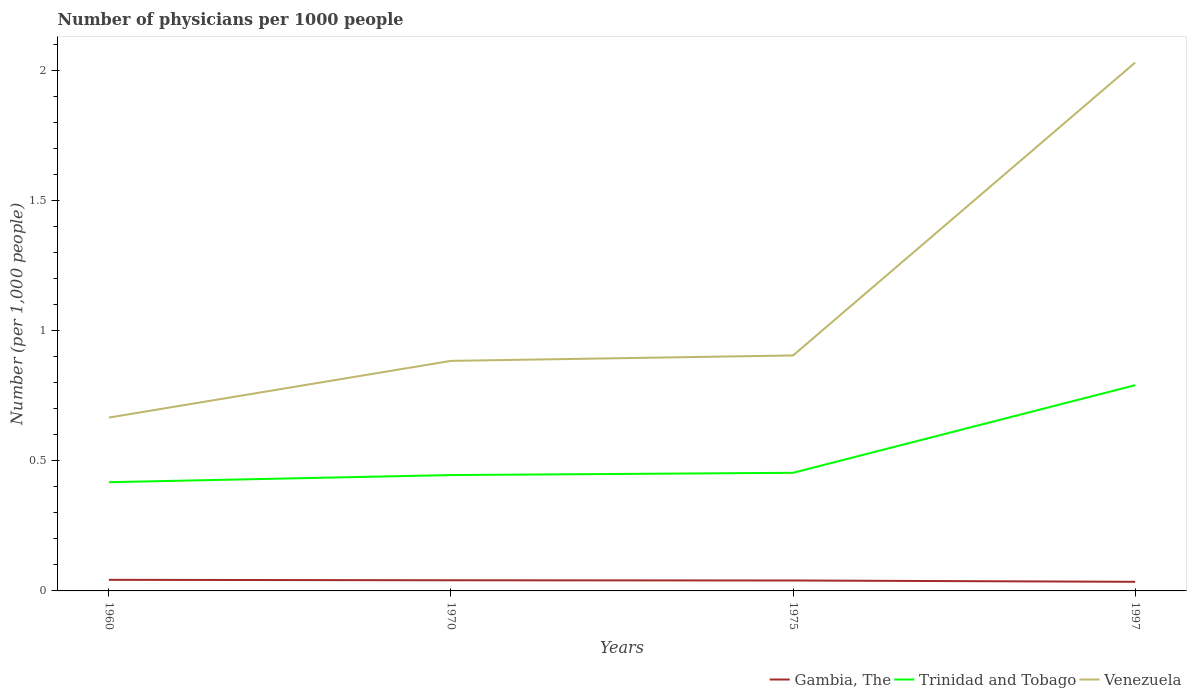How many different coloured lines are there?
Provide a short and direct response. 3. Is the number of lines equal to the number of legend labels?
Your answer should be compact. Yes. Across all years, what is the maximum number of physicians in Trinidad and Tobago?
Give a very brief answer. 0.42. What is the total number of physicians in Gambia, The in the graph?
Ensure brevity in your answer.  0.01. What is the difference between the highest and the second highest number of physicians in Venezuela?
Offer a very short reply. 1.36. How many lines are there?
Offer a very short reply. 3. How many years are there in the graph?
Give a very brief answer. 4. What is the difference between two consecutive major ticks on the Y-axis?
Make the answer very short. 0.5. Are the values on the major ticks of Y-axis written in scientific E-notation?
Your answer should be very brief. No. Does the graph contain any zero values?
Give a very brief answer. No. How are the legend labels stacked?
Ensure brevity in your answer.  Horizontal. What is the title of the graph?
Your answer should be very brief. Number of physicians per 1000 people. What is the label or title of the X-axis?
Keep it short and to the point. Years. What is the label or title of the Y-axis?
Keep it short and to the point. Number (per 1,0 people). What is the Number (per 1,000 people) of Gambia, The in 1960?
Give a very brief answer. 0.04. What is the Number (per 1,000 people) in Trinidad and Tobago in 1960?
Offer a very short reply. 0.42. What is the Number (per 1,000 people) in Venezuela in 1960?
Provide a succinct answer. 0.67. What is the Number (per 1,000 people) of Gambia, The in 1970?
Provide a short and direct response. 0.04. What is the Number (per 1,000 people) of Trinidad and Tobago in 1970?
Keep it short and to the point. 0.44. What is the Number (per 1,000 people) of Venezuela in 1970?
Your answer should be very brief. 0.88. What is the Number (per 1,000 people) in Gambia, The in 1975?
Offer a very short reply. 0.04. What is the Number (per 1,000 people) in Trinidad and Tobago in 1975?
Make the answer very short. 0.45. What is the Number (per 1,000 people) in Venezuela in 1975?
Offer a terse response. 0.9. What is the Number (per 1,000 people) of Gambia, The in 1997?
Give a very brief answer. 0.04. What is the Number (per 1,000 people) of Trinidad and Tobago in 1997?
Give a very brief answer. 0.79. What is the Number (per 1,000 people) in Venezuela in 1997?
Offer a terse response. 2.03. Across all years, what is the maximum Number (per 1,000 people) in Gambia, The?
Give a very brief answer. 0.04. Across all years, what is the maximum Number (per 1,000 people) of Trinidad and Tobago?
Ensure brevity in your answer.  0.79. Across all years, what is the maximum Number (per 1,000 people) of Venezuela?
Offer a very short reply. 2.03. Across all years, what is the minimum Number (per 1,000 people) in Gambia, The?
Keep it short and to the point. 0.04. Across all years, what is the minimum Number (per 1,000 people) of Trinidad and Tobago?
Provide a short and direct response. 0.42. Across all years, what is the minimum Number (per 1,000 people) in Venezuela?
Make the answer very short. 0.67. What is the total Number (per 1,000 people) in Gambia, The in the graph?
Offer a terse response. 0.16. What is the total Number (per 1,000 people) in Trinidad and Tobago in the graph?
Provide a short and direct response. 2.11. What is the total Number (per 1,000 people) in Venezuela in the graph?
Offer a terse response. 4.48. What is the difference between the Number (per 1,000 people) in Gambia, The in 1960 and that in 1970?
Your answer should be very brief. 0. What is the difference between the Number (per 1,000 people) of Trinidad and Tobago in 1960 and that in 1970?
Offer a very short reply. -0.03. What is the difference between the Number (per 1,000 people) in Venezuela in 1960 and that in 1970?
Provide a short and direct response. -0.22. What is the difference between the Number (per 1,000 people) in Gambia, The in 1960 and that in 1975?
Your response must be concise. 0. What is the difference between the Number (per 1,000 people) of Trinidad and Tobago in 1960 and that in 1975?
Give a very brief answer. -0.04. What is the difference between the Number (per 1,000 people) in Venezuela in 1960 and that in 1975?
Your answer should be very brief. -0.24. What is the difference between the Number (per 1,000 people) in Gambia, The in 1960 and that in 1997?
Your response must be concise. 0.01. What is the difference between the Number (per 1,000 people) of Trinidad and Tobago in 1960 and that in 1997?
Provide a succinct answer. -0.37. What is the difference between the Number (per 1,000 people) in Venezuela in 1960 and that in 1997?
Your answer should be very brief. -1.36. What is the difference between the Number (per 1,000 people) in Gambia, The in 1970 and that in 1975?
Keep it short and to the point. 0. What is the difference between the Number (per 1,000 people) in Trinidad and Tobago in 1970 and that in 1975?
Ensure brevity in your answer.  -0.01. What is the difference between the Number (per 1,000 people) of Venezuela in 1970 and that in 1975?
Provide a succinct answer. -0.02. What is the difference between the Number (per 1,000 people) of Gambia, The in 1970 and that in 1997?
Ensure brevity in your answer.  0.01. What is the difference between the Number (per 1,000 people) of Trinidad and Tobago in 1970 and that in 1997?
Your response must be concise. -0.35. What is the difference between the Number (per 1,000 people) of Venezuela in 1970 and that in 1997?
Offer a terse response. -1.15. What is the difference between the Number (per 1,000 people) in Gambia, The in 1975 and that in 1997?
Provide a succinct answer. 0.01. What is the difference between the Number (per 1,000 people) in Trinidad and Tobago in 1975 and that in 1997?
Provide a short and direct response. -0.34. What is the difference between the Number (per 1,000 people) in Venezuela in 1975 and that in 1997?
Your answer should be compact. -1.12. What is the difference between the Number (per 1,000 people) in Gambia, The in 1960 and the Number (per 1,000 people) in Trinidad and Tobago in 1970?
Give a very brief answer. -0.4. What is the difference between the Number (per 1,000 people) in Gambia, The in 1960 and the Number (per 1,000 people) in Venezuela in 1970?
Provide a short and direct response. -0.84. What is the difference between the Number (per 1,000 people) of Trinidad and Tobago in 1960 and the Number (per 1,000 people) of Venezuela in 1970?
Your response must be concise. -0.47. What is the difference between the Number (per 1,000 people) of Gambia, The in 1960 and the Number (per 1,000 people) of Trinidad and Tobago in 1975?
Your answer should be very brief. -0.41. What is the difference between the Number (per 1,000 people) in Gambia, The in 1960 and the Number (per 1,000 people) in Venezuela in 1975?
Ensure brevity in your answer.  -0.86. What is the difference between the Number (per 1,000 people) of Trinidad and Tobago in 1960 and the Number (per 1,000 people) of Venezuela in 1975?
Keep it short and to the point. -0.49. What is the difference between the Number (per 1,000 people) of Gambia, The in 1960 and the Number (per 1,000 people) of Trinidad and Tobago in 1997?
Make the answer very short. -0.75. What is the difference between the Number (per 1,000 people) of Gambia, The in 1960 and the Number (per 1,000 people) of Venezuela in 1997?
Provide a succinct answer. -1.99. What is the difference between the Number (per 1,000 people) in Trinidad and Tobago in 1960 and the Number (per 1,000 people) in Venezuela in 1997?
Your response must be concise. -1.61. What is the difference between the Number (per 1,000 people) in Gambia, The in 1970 and the Number (per 1,000 people) in Trinidad and Tobago in 1975?
Keep it short and to the point. -0.41. What is the difference between the Number (per 1,000 people) of Gambia, The in 1970 and the Number (per 1,000 people) of Venezuela in 1975?
Offer a very short reply. -0.86. What is the difference between the Number (per 1,000 people) of Trinidad and Tobago in 1970 and the Number (per 1,000 people) of Venezuela in 1975?
Ensure brevity in your answer.  -0.46. What is the difference between the Number (per 1,000 people) in Gambia, The in 1970 and the Number (per 1,000 people) in Trinidad and Tobago in 1997?
Your answer should be compact. -0.75. What is the difference between the Number (per 1,000 people) in Gambia, The in 1970 and the Number (per 1,000 people) in Venezuela in 1997?
Your answer should be compact. -1.99. What is the difference between the Number (per 1,000 people) of Trinidad and Tobago in 1970 and the Number (per 1,000 people) of Venezuela in 1997?
Keep it short and to the point. -1.58. What is the difference between the Number (per 1,000 people) of Gambia, The in 1975 and the Number (per 1,000 people) of Trinidad and Tobago in 1997?
Ensure brevity in your answer.  -0.75. What is the difference between the Number (per 1,000 people) in Gambia, The in 1975 and the Number (per 1,000 people) in Venezuela in 1997?
Your answer should be very brief. -1.99. What is the difference between the Number (per 1,000 people) in Trinidad and Tobago in 1975 and the Number (per 1,000 people) in Venezuela in 1997?
Give a very brief answer. -1.58. What is the average Number (per 1,000 people) of Gambia, The per year?
Give a very brief answer. 0.04. What is the average Number (per 1,000 people) of Trinidad and Tobago per year?
Make the answer very short. 0.53. What is the average Number (per 1,000 people) of Venezuela per year?
Offer a very short reply. 1.12. In the year 1960, what is the difference between the Number (per 1,000 people) of Gambia, The and Number (per 1,000 people) of Trinidad and Tobago?
Offer a very short reply. -0.37. In the year 1960, what is the difference between the Number (per 1,000 people) in Gambia, The and Number (per 1,000 people) in Venezuela?
Your response must be concise. -0.62. In the year 1960, what is the difference between the Number (per 1,000 people) of Trinidad and Tobago and Number (per 1,000 people) of Venezuela?
Offer a terse response. -0.25. In the year 1970, what is the difference between the Number (per 1,000 people) in Gambia, The and Number (per 1,000 people) in Trinidad and Tobago?
Offer a very short reply. -0.4. In the year 1970, what is the difference between the Number (per 1,000 people) in Gambia, The and Number (per 1,000 people) in Venezuela?
Your response must be concise. -0.84. In the year 1970, what is the difference between the Number (per 1,000 people) of Trinidad and Tobago and Number (per 1,000 people) of Venezuela?
Give a very brief answer. -0.44. In the year 1975, what is the difference between the Number (per 1,000 people) in Gambia, The and Number (per 1,000 people) in Trinidad and Tobago?
Your answer should be compact. -0.41. In the year 1975, what is the difference between the Number (per 1,000 people) in Gambia, The and Number (per 1,000 people) in Venezuela?
Provide a succinct answer. -0.86. In the year 1975, what is the difference between the Number (per 1,000 people) of Trinidad and Tobago and Number (per 1,000 people) of Venezuela?
Ensure brevity in your answer.  -0.45. In the year 1997, what is the difference between the Number (per 1,000 people) in Gambia, The and Number (per 1,000 people) in Trinidad and Tobago?
Offer a terse response. -0.76. In the year 1997, what is the difference between the Number (per 1,000 people) of Gambia, The and Number (per 1,000 people) of Venezuela?
Offer a terse response. -1.99. In the year 1997, what is the difference between the Number (per 1,000 people) of Trinidad and Tobago and Number (per 1,000 people) of Venezuela?
Provide a short and direct response. -1.24. What is the ratio of the Number (per 1,000 people) of Gambia, The in 1960 to that in 1970?
Ensure brevity in your answer.  1.04. What is the ratio of the Number (per 1,000 people) of Trinidad and Tobago in 1960 to that in 1970?
Your response must be concise. 0.94. What is the ratio of the Number (per 1,000 people) in Venezuela in 1960 to that in 1970?
Provide a short and direct response. 0.75. What is the ratio of the Number (per 1,000 people) of Gambia, The in 1960 to that in 1975?
Your response must be concise. 1.06. What is the ratio of the Number (per 1,000 people) of Trinidad and Tobago in 1960 to that in 1975?
Your response must be concise. 0.92. What is the ratio of the Number (per 1,000 people) in Venezuela in 1960 to that in 1975?
Your answer should be compact. 0.74. What is the ratio of the Number (per 1,000 people) of Gambia, The in 1960 to that in 1997?
Provide a succinct answer. 1.22. What is the ratio of the Number (per 1,000 people) in Trinidad and Tobago in 1960 to that in 1997?
Ensure brevity in your answer.  0.53. What is the ratio of the Number (per 1,000 people) in Venezuela in 1960 to that in 1997?
Make the answer very short. 0.33. What is the ratio of the Number (per 1,000 people) of Gambia, The in 1970 to that in 1975?
Offer a terse response. 1.02. What is the ratio of the Number (per 1,000 people) in Trinidad and Tobago in 1970 to that in 1975?
Give a very brief answer. 0.98. What is the ratio of the Number (per 1,000 people) in Venezuela in 1970 to that in 1975?
Provide a short and direct response. 0.98. What is the ratio of the Number (per 1,000 people) of Gambia, The in 1970 to that in 1997?
Your answer should be very brief. 1.17. What is the ratio of the Number (per 1,000 people) of Trinidad and Tobago in 1970 to that in 1997?
Provide a succinct answer. 0.56. What is the ratio of the Number (per 1,000 people) in Venezuela in 1970 to that in 1997?
Ensure brevity in your answer.  0.44. What is the ratio of the Number (per 1,000 people) in Gambia, The in 1975 to that in 1997?
Ensure brevity in your answer.  1.15. What is the ratio of the Number (per 1,000 people) of Trinidad and Tobago in 1975 to that in 1997?
Give a very brief answer. 0.57. What is the ratio of the Number (per 1,000 people) in Venezuela in 1975 to that in 1997?
Your response must be concise. 0.45. What is the difference between the highest and the second highest Number (per 1,000 people) of Gambia, The?
Give a very brief answer. 0. What is the difference between the highest and the second highest Number (per 1,000 people) of Trinidad and Tobago?
Offer a terse response. 0.34. What is the difference between the highest and the second highest Number (per 1,000 people) of Venezuela?
Provide a short and direct response. 1.12. What is the difference between the highest and the lowest Number (per 1,000 people) in Gambia, The?
Provide a succinct answer. 0.01. What is the difference between the highest and the lowest Number (per 1,000 people) in Trinidad and Tobago?
Provide a short and direct response. 0.37. What is the difference between the highest and the lowest Number (per 1,000 people) of Venezuela?
Give a very brief answer. 1.36. 